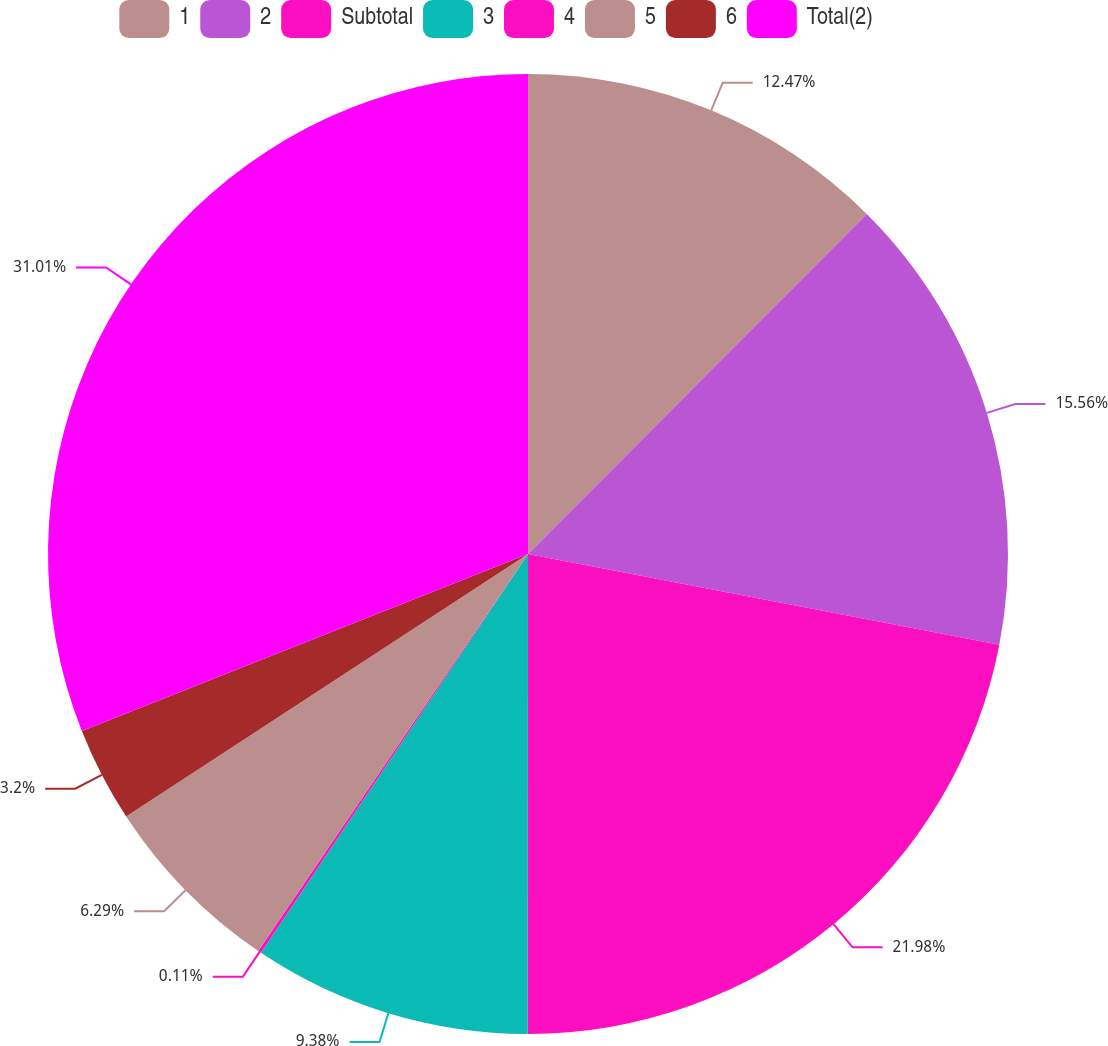Convert chart to OTSL. <chart><loc_0><loc_0><loc_500><loc_500><pie_chart><fcel>1<fcel>2<fcel>Subtotal<fcel>3<fcel>4<fcel>5<fcel>6<fcel>Total(2)<nl><fcel>12.47%<fcel>15.56%<fcel>21.98%<fcel>9.38%<fcel>0.11%<fcel>6.29%<fcel>3.2%<fcel>31.01%<nl></chart> 